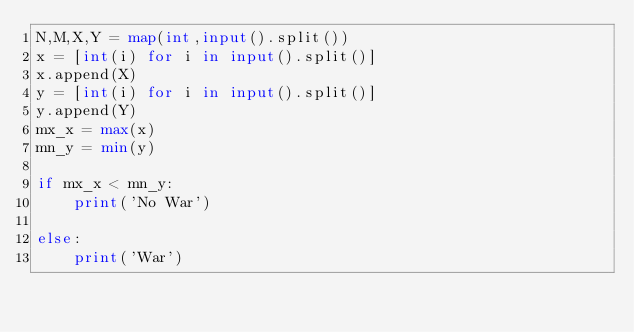<code> <loc_0><loc_0><loc_500><loc_500><_Python_>N,M,X,Y = map(int,input().split())
x = [int(i) for i in input().split()]
x.append(X)
y = [int(i) for i in input().split()]
y.append(Y)
mx_x = max(x)
mn_y = min(y)

if mx_x < mn_y:
    print('No War')
    
else:
    print('War')</code> 